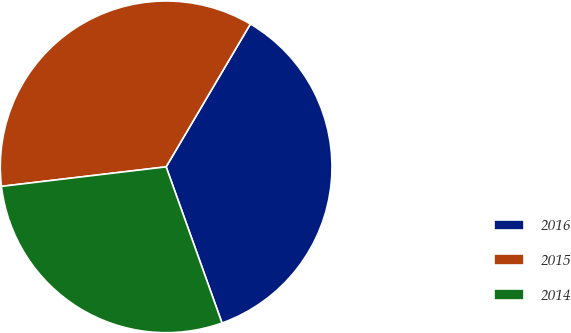<chart> <loc_0><loc_0><loc_500><loc_500><pie_chart><fcel>2016<fcel>2015<fcel>2014<nl><fcel>36.05%<fcel>35.36%<fcel>28.59%<nl></chart> 